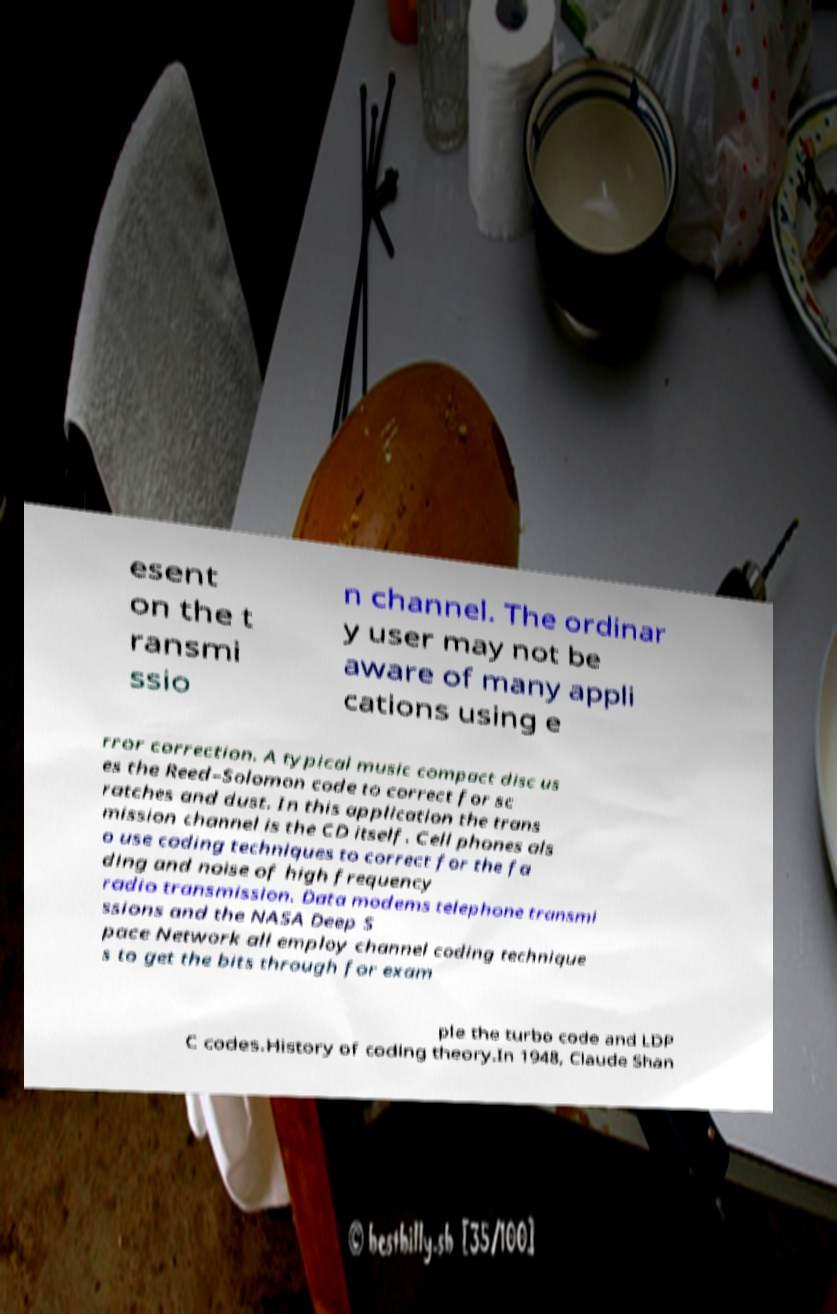I need the written content from this picture converted into text. Can you do that? esent on the t ransmi ssio n channel. The ordinar y user may not be aware of many appli cations using e rror correction. A typical music compact disc us es the Reed–Solomon code to correct for sc ratches and dust. In this application the trans mission channel is the CD itself. Cell phones als o use coding techniques to correct for the fa ding and noise of high frequency radio transmission. Data modems telephone transmi ssions and the NASA Deep S pace Network all employ channel coding technique s to get the bits through for exam ple the turbo code and LDP C codes.History of coding theory.In 1948, Claude Shan 